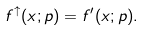Convert formula to latex. <formula><loc_0><loc_0><loc_500><loc_500>f ^ { \uparrow } ( x ; p ) = f ^ { \prime } ( x ; p ) .</formula> 